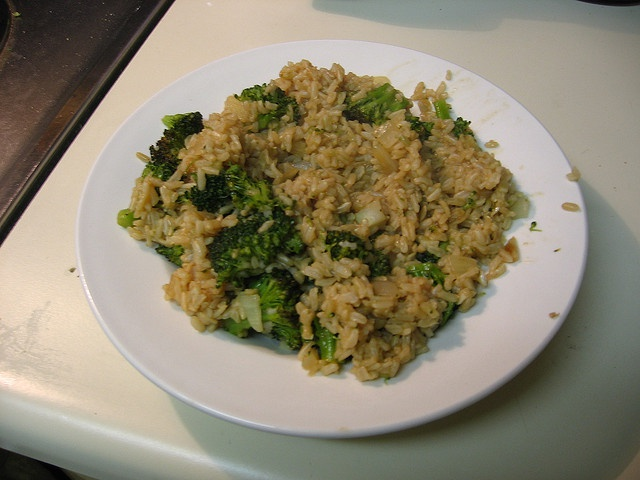Describe the objects in this image and their specific colors. I can see broccoli in black, darkgreen, and gray tones, broccoli in black, darkgreen, and olive tones, broccoli in black and darkgreen tones, broccoli in black, darkgreen, and olive tones, and broccoli in black, darkgreen, and olive tones in this image. 